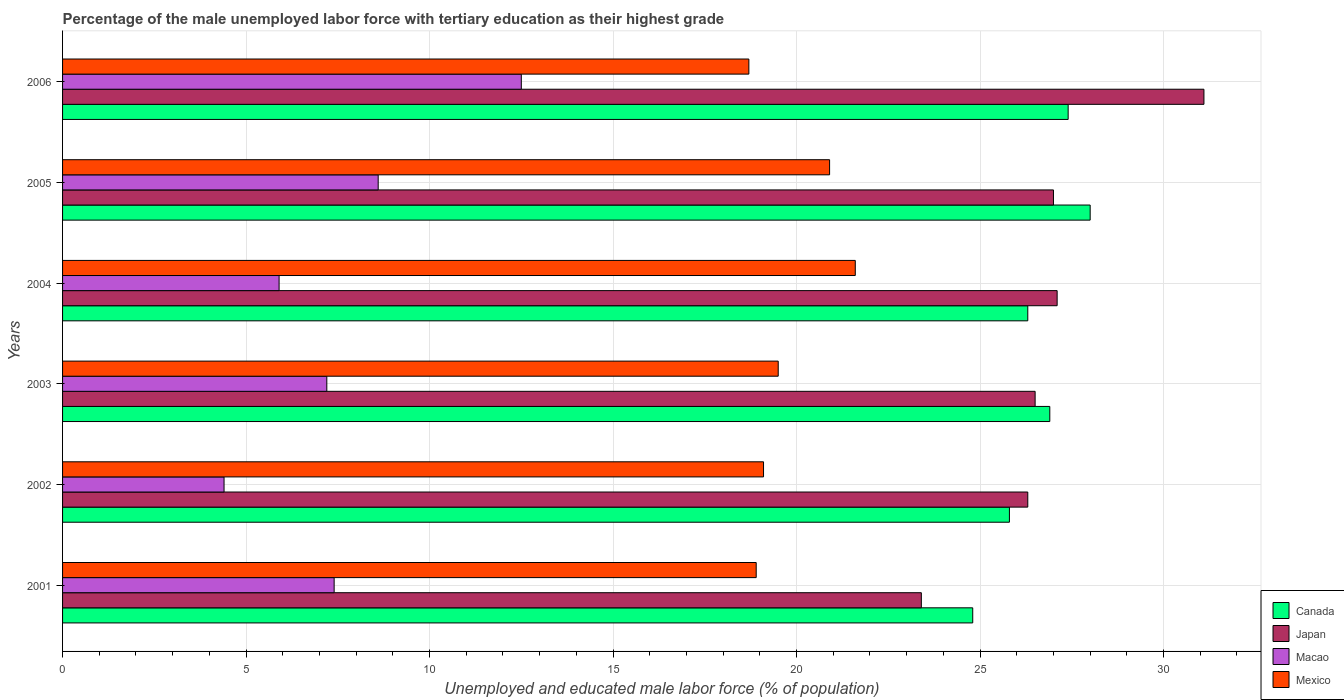How many different coloured bars are there?
Ensure brevity in your answer.  4. Are the number of bars per tick equal to the number of legend labels?
Your response must be concise. Yes. Are the number of bars on each tick of the Y-axis equal?
Provide a short and direct response. Yes. What is the label of the 3rd group of bars from the top?
Make the answer very short. 2004. What is the percentage of the unemployed male labor force with tertiary education in Canada in 2004?
Give a very brief answer. 26.3. Across all years, what is the maximum percentage of the unemployed male labor force with tertiary education in Canada?
Provide a short and direct response. 28. Across all years, what is the minimum percentage of the unemployed male labor force with tertiary education in Macao?
Offer a terse response. 4.4. In which year was the percentage of the unemployed male labor force with tertiary education in Japan maximum?
Your answer should be very brief. 2006. What is the total percentage of the unemployed male labor force with tertiary education in Canada in the graph?
Your answer should be very brief. 159.2. What is the difference between the percentage of the unemployed male labor force with tertiary education in Canada in 2004 and that in 2005?
Your response must be concise. -1.7. What is the difference between the percentage of the unemployed male labor force with tertiary education in Mexico in 2001 and the percentage of the unemployed male labor force with tertiary education in Canada in 2003?
Provide a short and direct response. -8. What is the average percentage of the unemployed male labor force with tertiary education in Macao per year?
Provide a short and direct response. 7.67. In the year 2004, what is the difference between the percentage of the unemployed male labor force with tertiary education in Japan and percentage of the unemployed male labor force with tertiary education in Mexico?
Your answer should be compact. 5.5. In how many years, is the percentage of the unemployed male labor force with tertiary education in Macao greater than 24 %?
Offer a terse response. 0. What is the ratio of the percentage of the unemployed male labor force with tertiary education in Japan in 2002 to that in 2003?
Offer a terse response. 0.99. Is the percentage of the unemployed male labor force with tertiary education in Canada in 2002 less than that in 2004?
Your response must be concise. Yes. Is the difference between the percentage of the unemployed male labor force with tertiary education in Japan in 2004 and 2006 greater than the difference between the percentage of the unemployed male labor force with tertiary education in Mexico in 2004 and 2006?
Your response must be concise. No. What is the difference between the highest and the second highest percentage of the unemployed male labor force with tertiary education in Mexico?
Keep it short and to the point. 0.7. What is the difference between the highest and the lowest percentage of the unemployed male labor force with tertiary education in Mexico?
Your response must be concise. 2.9. In how many years, is the percentage of the unemployed male labor force with tertiary education in Japan greater than the average percentage of the unemployed male labor force with tertiary education in Japan taken over all years?
Provide a succinct answer. 3. Is the sum of the percentage of the unemployed male labor force with tertiary education in Macao in 2002 and 2006 greater than the maximum percentage of the unemployed male labor force with tertiary education in Japan across all years?
Provide a succinct answer. No. Is it the case that in every year, the sum of the percentage of the unemployed male labor force with tertiary education in Japan and percentage of the unemployed male labor force with tertiary education in Macao is greater than the sum of percentage of the unemployed male labor force with tertiary education in Canada and percentage of the unemployed male labor force with tertiary education in Mexico?
Give a very brief answer. No. Is it the case that in every year, the sum of the percentage of the unemployed male labor force with tertiary education in Mexico and percentage of the unemployed male labor force with tertiary education in Macao is greater than the percentage of the unemployed male labor force with tertiary education in Canada?
Provide a short and direct response. No. How many years are there in the graph?
Offer a terse response. 6. Does the graph contain grids?
Offer a very short reply. Yes. How many legend labels are there?
Give a very brief answer. 4. What is the title of the graph?
Keep it short and to the point. Percentage of the male unemployed labor force with tertiary education as their highest grade. What is the label or title of the X-axis?
Provide a succinct answer. Unemployed and educated male labor force (% of population). What is the label or title of the Y-axis?
Provide a short and direct response. Years. What is the Unemployed and educated male labor force (% of population) of Canada in 2001?
Provide a succinct answer. 24.8. What is the Unemployed and educated male labor force (% of population) in Japan in 2001?
Offer a very short reply. 23.4. What is the Unemployed and educated male labor force (% of population) in Macao in 2001?
Offer a terse response. 7.4. What is the Unemployed and educated male labor force (% of population) in Mexico in 2001?
Provide a short and direct response. 18.9. What is the Unemployed and educated male labor force (% of population) of Canada in 2002?
Your answer should be very brief. 25.8. What is the Unemployed and educated male labor force (% of population) in Japan in 2002?
Offer a very short reply. 26.3. What is the Unemployed and educated male labor force (% of population) in Macao in 2002?
Your answer should be compact. 4.4. What is the Unemployed and educated male labor force (% of population) in Mexico in 2002?
Your answer should be compact. 19.1. What is the Unemployed and educated male labor force (% of population) of Canada in 2003?
Provide a succinct answer. 26.9. What is the Unemployed and educated male labor force (% of population) in Macao in 2003?
Your answer should be very brief. 7.2. What is the Unemployed and educated male labor force (% of population) in Canada in 2004?
Make the answer very short. 26.3. What is the Unemployed and educated male labor force (% of population) of Japan in 2004?
Your answer should be very brief. 27.1. What is the Unemployed and educated male labor force (% of population) in Macao in 2004?
Keep it short and to the point. 5.9. What is the Unemployed and educated male labor force (% of population) in Mexico in 2004?
Provide a succinct answer. 21.6. What is the Unemployed and educated male labor force (% of population) in Canada in 2005?
Your response must be concise. 28. What is the Unemployed and educated male labor force (% of population) in Macao in 2005?
Ensure brevity in your answer.  8.6. What is the Unemployed and educated male labor force (% of population) of Mexico in 2005?
Offer a very short reply. 20.9. What is the Unemployed and educated male labor force (% of population) in Canada in 2006?
Your response must be concise. 27.4. What is the Unemployed and educated male labor force (% of population) in Japan in 2006?
Provide a short and direct response. 31.1. What is the Unemployed and educated male labor force (% of population) of Mexico in 2006?
Offer a very short reply. 18.7. Across all years, what is the maximum Unemployed and educated male labor force (% of population) in Canada?
Give a very brief answer. 28. Across all years, what is the maximum Unemployed and educated male labor force (% of population) in Japan?
Make the answer very short. 31.1. Across all years, what is the maximum Unemployed and educated male labor force (% of population) in Macao?
Your answer should be compact. 12.5. Across all years, what is the maximum Unemployed and educated male labor force (% of population) in Mexico?
Your response must be concise. 21.6. Across all years, what is the minimum Unemployed and educated male labor force (% of population) in Canada?
Your response must be concise. 24.8. Across all years, what is the minimum Unemployed and educated male labor force (% of population) of Japan?
Your response must be concise. 23.4. Across all years, what is the minimum Unemployed and educated male labor force (% of population) of Macao?
Give a very brief answer. 4.4. Across all years, what is the minimum Unemployed and educated male labor force (% of population) of Mexico?
Provide a short and direct response. 18.7. What is the total Unemployed and educated male labor force (% of population) in Canada in the graph?
Provide a short and direct response. 159.2. What is the total Unemployed and educated male labor force (% of population) of Japan in the graph?
Ensure brevity in your answer.  161.4. What is the total Unemployed and educated male labor force (% of population) in Macao in the graph?
Offer a very short reply. 46. What is the total Unemployed and educated male labor force (% of population) in Mexico in the graph?
Offer a terse response. 118.7. What is the difference between the Unemployed and educated male labor force (% of population) of Japan in 2001 and that in 2002?
Offer a very short reply. -2.9. What is the difference between the Unemployed and educated male labor force (% of population) in Macao in 2001 and that in 2002?
Provide a succinct answer. 3. What is the difference between the Unemployed and educated male labor force (% of population) of Japan in 2001 and that in 2003?
Give a very brief answer. -3.1. What is the difference between the Unemployed and educated male labor force (% of population) of Mexico in 2001 and that in 2003?
Your answer should be very brief. -0.6. What is the difference between the Unemployed and educated male labor force (% of population) in Canada in 2001 and that in 2004?
Your answer should be compact. -1.5. What is the difference between the Unemployed and educated male labor force (% of population) in Japan in 2001 and that in 2004?
Offer a terse response. -3.7. What is the difference between the Unemployed and educated male labor force (% of population) of Macao in 2001 and that in 2004?
Provide a short and direct response. 1.5. What is the difference between the Unemployed and educated male labor force (% of population) of Mexico in 2001 and that in 2004?
Offer a very short reply. -2.7. What is the difference between the Unemployed and educated male labor force (% of population) of Canada in 2001 and that in 2005?
Keep it short and to the point. -3.2. What is the difference between the Unemployed and educated male labor force (% of population) of Japan in 2001 and that in 2006?
Provide a succinct answer. -7.7. What is the difference between the Unemployed and educated male labor force (% of population) in Mexico in 2002 and that in 2003?
Provide a short and direct response. -0.4. What is the difference between the Unemployed and educated male labor force (% of population) in Japan in 2002 and that in 2004?
Make the answer very short. -0.8. What is the difference between the Unemployed and educated male labor force (% of population) in Macao in 2002 and that in 2004?
Provide a succinct answer. -1.5. What is the difference between the Unemployed and educated male labor force (% of population) in Mexico in 2002 and that in 2004?
Provide a short and direct response. -2.5. What is the difference between the Unemployed and educated male labor force (% of population) of Macao in 2002 and that in 2005?
Keep it short and to the point. -4.2. What is the difference between the Unemployed and educated male labor force (% of population) in Mexico in 2002 and that in 2005?
Your answer should be very brief. -1.8. What is the difference between the Unemployed and educated male labor force (% of population) in Canada in 2002 and that in 2006?
Make the answer very short. -1.6. What is the difference between the Unemployed and educated male labor force (% of population) in Japan in 2002 and that in 2006?
Keep it short and to the point. -4.8. What is the difference between the Unemployed and educated male labor force (% of population) in Japan in 2003 and that in 2004?
Your answer should be compact. -0.6. What is the difference between the Unemployed and educated male labor force (% of population) in Mexico in 2003 and that in 2004?
Provide a succinct answer. -2.1. What is the difference between the Unemployed and educated male labor force (% of population) of Macao in 2003 and that in 2005?
Make the answer very short. -1.4. What is the difference between the Unemployed and educated male labor force (% of population) of Canada in 2004 and that in 2005?
Your answer should be compact. -1.7. What is the difference between the Unemployed and educated male labor force (% of population) of Japan in 2004 and that in 2005?
Provide a short and direct response. 0.1. What is the difference between the Unemployed and educated male labor force (% of population) of Mexico in 2004 and that in 2005?
Offer a very short reply. 0.7. What is the difference between the Unemployed and educated male labor force (% of population) of Japan in 2004 and that in 2006?
Make the answer very short. -4. What is the difference between the Unemployed and educated male labor force (% of population) of Mexico in 2004 and that in 2006?
Offer a terse response. 2.9. What is the difference between the Unemployed and educated male labor force (% of population) of Canada in 2005 and that in 2006?
Make the answer very short. 0.6. What is the difference between the Unemployed and educated male labor force (% of population) in Japan in 2005 and that in 2006?
Offer a very short reply. -4.1. What is the difference between the Unemployed and educated male labor force (% of population) of Macao in 2005 and that in 2006?
Your answer should be very brief. -3.9. What is the difference between the Unemployed and educated male labor force (% of population) in Mexico in 2005 and that in 2006?
Your answer should be compact. 2.2. What is the difference between the Unemployed and educated male labor force (% of population) of Canada in 2001 and the Unemployed and educated male labor force (% of population) of Macao in 2002?
Your answer should be very brief. 20.4. What is the difference between the Unemployed and educated male labor force (% of population) of Canada in 2001 and the Unemployed and educated male labor force (% of population) of Mexico in 2002?
Offer a terse response. 5.7. What is the difference between the Unemployed and educated male labor force (% of population) in Japan in 2001 and the Unemployed and educated male labor force (% of population) in Macao in 2002?
Make the answer very short. 19. What is the difference between the Unemployed and educated male labor force (% of population) of Macao in 2001 and the Unemployed and educated male labor force (% of population) of Mexico in 2002?
Give a very brief answer. -11.7. What is the difference between the Unemployed and educated male labor force (% of population) of Canada in 2001 and the Unemployed and educated male labor force (% of population) of Japan in 2003?
Your answer should be compact. -1.7. What is the difference between the Unemployed and educated male labor force (% of population) of Japan in 2001 and the Unemployed and educated male labor force (% of population) of Mexico in 2003?
Your response must be concise. 3.9. What is the difference between the Unemployed and educated male labor force (% of population) of Japan in 2001 and the Unemployed and educated male labor force (% of population) of Macao in 2004?
Your answer should be very brief. 17.5. What is the difference between the Unemployed and educated male labor force (% of population) in Canada in 2001 and the Unemployed and educated male labor force (% of population) in Mexico in 2005?
Make the answer very short. 3.9. What is the difference between the Unemployed and educated male labor force (% of population) of Japan in 2001 and the Unemployed and educated male labor force (% of population) of Macao in 2005?
Offer a terse response. 14.8. What is the difference between the Unemployed and educated male labor force (% of population) of Canada in 2002 and the Unemployed and educated male labor force (% of population) of Macao in 2003?
Offer a very short reply. 18.6. What is the difference between the Unemployed and educated male labor force (% of population) in Japan in 2002 and the Unemployed and educated male labor force (% of population) in Macao in 2003?
Provide a succinct answer. 19.1. What is the difference between the Unemployed and educated male labor force (% of population) of Japan in 2002 and the Unemployed and educated male labor force (% of population) of Mexico in 2003?
Give a very brief answer. 6.8. What is the difference between the Unemployed and educated male labor force (% of population) of Macao in 2002 and the Unemployed and educated male labor force (% of population) of Mexico in 2003?
Give a very brief answer. -15.1. What is the difference between the Unemployed and educated male labor force (% of population) of Canada in 2002 and the Unemployed and educated male labor force (% of population) of Japan in 2004?
Offer a terse response. -1.3. What is the difference between the Unemployed and educated male labor force (% of population) of Canada in 2002 and the Unemployed and educated male labor force (% of population) of Macao in 2004?
Your answer should be compact. 19.9. What is the difference between the Unemployed and educated male labor force (% of population) of Japan in 2002 and the Unemployed and educated male labor force (% of population) of Macao in 2004?
Give a very brief answer. 20.4. What is the difference between the Unemployed and educated male labor force (% of population) in Macao in 2002 and the Unemployed and educated male labor force (% of population) in Mexico in 2004?
Give a very brief answer. -17.2. What is the difference between the Unemployed and educated male labor force (% of population) in Canada in 2002 and the Unemployed and educated male labor force (% of population) in Japan in 2005?
Ensure brevity in your answer.  -1.2. What is the difference between the Unemployed and educated male labor force (% of population) in Canada in 2002 and the Unemployed and educated male labor force (% of population) in Macao in 2005?
Make the answer very short. 17.2. What is the difference between the Unemployed and educated male labor force (% of population) of Japan in 2002 and the Unemployed and educated male labor force (% of population) of Mexico in 2005?
Provide a short and direct response. 5.4. What is the difference between the Unemployed and educated male labor force (% of population) in Macao in 2002 and the Unemployed and educated male labor force (% of population) in Mexico in 2005?
Make the answer very short. -16.5. What is the difference between the Unemployed and educated male labor force (% of population) in Canada in 2002 and the Unemployed and educated male labor force (% of population) in Mexico in 2006?
Provide a short and direct response. 7.1. What is the difference between the Unemployed and educated male labor force (% of population) of Japan in 2002 and the Unemployed and educated male labor force (% of population) of Macao in 2006?
Offer a terse response. 13.8. What is the difference between the Unemployed and educated male labor force (% of population) of Macao in 2002 and the Unemployed and educated male labor force (% of population) of Mexico in 2006?
Your response must be concise. -14.3. What is the difference between the Unemployed and educated male labor force (% of population) in Canada in 2003 and the Unemployed and educated male labor force (% of population) in Japan in 2004?
Provide a short and direct response. -0.2. What is the difference between the Unemployed and educated male labor force (% of population) of Japan in 2003 and the Unemployed and educated male labor force (% of population) of Macao in 2004?
Keep it short and to the point. 20.6. What is the difference between the Unemployed and educated male labor force (% of population) of Macao in 2003 and the Unemployed and educated male labor force (% of population) of Mexico in 2004?
Your response must be concise. -14.4. What is the difference between the Unemployed and educated male labor force (% of population) in Canada in 2003 and the Unemployed and educated male labor force (% of population) in Japan in 2005?
Your response must be concise. -0.1. What is the difference between the Unemployed and educated male labor force (% of population) in Canada in 2003 and the Unemployed and educated male labor force (% of population) in Macao in 2005?
Offer a very short reply. 18.3. What is the difference between the Unemployed and educated male labor force (% of population) of Japan in 2003 and the Unemployed and educated male labor force (% of population) of Macao in 2005?
Offer a very short reply. 17.9. What is the difference between the Unemployed and educated male labor force (% of population) of Macao in 2003 and the Unemployed and educated male labor force (% of population) of Mexico in 2005?
Offer a terse response. -13.7. What is the difference between the Unemployed and educated male labor force (% of population) in Canada in 2003 and the Unemployed and educated male labor force (% of population) in Japan in 2006?
Your answer should be very brief. -4.2. What is the difference between the Unemployed and educated male labor force (% of population) of Canada in 2003 and the Unemployed and educated male labor force (% of population) of Macao in 2006?
Offer a very short reply. 14.4. What is the difference between the Unemployed and educated male labor force (% of population) in Canada in 2003 and the Unemployed and educated male labor force (% of population) in Mexico in 2006?
Offer a terse response. 8.2. What is the difference between the Unemployed and educated male labor force (% of population) of Macao in 2003 and the Unemployed and educated male labor force (% of population) of Mexico in 2006?
Offer a very short reply. -11.5. What is the difference between the Unemployed and educated male labor force (% of population) of Canada in 2004 and the Unemployed and educated male labor force (% of population) of Macao in 2005?
Make the answer very short. 17.7. What is the difference between the Unemployed and educated male labor force (% of population) in Japan in 2004 and the Unemployed and educated male labor force (% of population) in Mexico in 2005?
Make the answer very short. 6.2. What is the difference between the Unemployed and educated male labor force (% of population) of Canada in 2004 and the Unemployed and educated male labor force (% of population) of Japan in 2006?
Ensure brevity in your answer.  -4.8. What is the difference between the Unemployed and educated male labor force (% of population) in Japan in 2004 and the Unemployed and educated male labor force (% of population) in Macao in 2006?
Keep it short and to the point. 14.6. What is the difference between the Unemployed and educated male labor force (% of population) of Japan in 2004 and the Unemployed and educated male labor force (% of population) of Mexico in 2006?
Your response must be concise. 8.4. What is the difference between the Unemployed and educated male labor force (% of population) in Macao in 2004 and the Unemployed and educated male labor force (% of population) in Mexico in 2006?
Your answer should be very brief. -12.8. What is the difference between the Unemployed and educated male labor force (% of population) of Canada in 2005 and the Unemployed and educated male labor force (% of population) of Japan in 2006?
Provide a short and direct response. -3.1. What is the difference between the Unemployed and educated male labor force (% of population) of Japan in 2005 and the Unemployed and educated male labor force (% of population) of Mexico in 2006?
Give a very brief answer. 8.3. What is the average Unemployed and educated male labor force (% of population) in Canada per year?
Provide a short and direct response. 26.53. What is the average Unemployed and educated male labor force (% of population) in Japan per year?
Provide a succinct answer. 26.9. What is the average Unemployed and educated male labor force (% of population) of Macao per year?
Offer a terse response. 7.67. What is the average Unemployed and educated male labor force (% of population) of Mexico per year?
Your answer should be very brief. 19.78. In the year 2001, what is the difference between the Unemployed and educated male labor force (% of population) in Macao and Unemployed and educated male labor force (% of population) in Mexico?
Provide a succinct answer. -11.5. In the year 2002, what is the difference between the Unemployed and educated male labor force (% of population) of Canada and Unemployed and educated male labor force (% of population) of Macao?
Make the answer very short. 21.4. In the year 2002, what is the difference between the Unemployed and educated male labor force (% of population) in Canada and Unemployed and educated male labor force (% of population) in Mexico?
Keep it short and to the point. 6.7. In the year 2002, what is the difference between the Unemployed and educated male labor force (% of population) in Japan and Unemployed and educated male labor force (% of population) in Macao?
Offer a very short reply. 21.9. In the year 2002, what is the difference between the Unemployed and educated male labor force (% of population) of Japan and Unemployed and educated male labor force (% of population) of Mexico?
Your response must be concise. 7.2. In the year 2002, what is the difference between the Unemployed and educated male labor force (% of population) in Macao and Unemployed and educated male labor force (% of population) in Mexico?
Keep it short and to the point. -14.7. In the year 2003, what is the difference between the Unemployed and educated male labor force (% of population) in Canada and Unemployed and educated male labor force (% of population) in Macao?
Your answer should be compact. 19.7. In the year 2003, what is the difference between the Unemployed and educated male labor force (% of population) in Canada and Unemployed and educated male labor force (% of population) in Mexico?
Offer a terse response. 7.4. In the year 2003, what is the difference between the Unemployed and educated male labor force (% of population) in Japan and Unemployed and educated male labor force (% of population) in Macao?
Offer a very short reply. 19.3. In the year 2003, what is the difference between the Unemployed and educated male labor force (% of population) in Japan and Unemployed and educated male labor force (% of population) in Mexico?
Your response must be concise. 7. In the year 2004, what is the difference between the Unemployed and educated male labor force (% of population) in Canada and Unemployed and educated male labor force (% of population) in Macao?
Give a very brief answer. 20.4. In the year 2004, what is the difference between the Unemployed and educated male labor force (% of population) in Canada and Unemployed and educated male labor force (% of population) in Mexico?
Make the answer very short. 4.7. In the year 2004, what is the difference between the Unemployed and educated male labor force (% of population) in Japan and Unemployed and educated male labor force (% of population) in Macao?
Provide a short and direct response. 21.2. In the year 2004, what is the difference between the Unemployed and educated male labor force (% of population) in Japan and Unemployed and educated male labor force (% of population) in Mexico?
Ensure brevity in your answer.  5.5. In the year 2004, what is the difference between the Unemployed and educated male labor force (% of population) of Macao and Unemployed and educated male labor force (% of population) of Mexico?
Your answer should be very brief. -15.7. In the year 2005, what is the difference between the Unemployed and educated male labor force (% of population) of Canada and Unemployed and educated male labor force (% of population) of Japan?
Offer a terse response. 1. In the year 2005, what is the difference between the Unemployed and educated male labor force (% of population) of Canada and Unemployed and educated male labor force (% of population) of Macao?
Your response must be concise. 19.4. In the year 2006, what is the difference between the Unemployed and educated male labor force (% of population) in Canada and Unemployed and educated male labor force (% of population) in Japan?
Ensure brevity in your answer.  -3.7. In the year 2006, what is the difference between the Unemployed and educated male labor force (% of population) of Canada and Unemployed and educated male labor force (% of population) of Mexico?
Your answer should be very brief. 8.7. In the year 2006, what is the difference between the Unemployed and educated male labor force (% of population) of Japan and Unemployed and educated male labor force (% of population) of Mexico?
Make the answer very short. 12.4. What is the ratio of the Unemployed and educated male labor force (% of population) of Canada in 2001 to that in 2002?
Offer a very short reply. 0.96. What is the ratio of the Unemployed and educated male labor force (% of population) of Japan in 2001 to that in 2002?
Provide a succinct answer. 0.89. What is the ratio of the Unemployed and educated male labor force (% of population) in Macao in 2001 to that in 2002?
Make the answer very short. 1.68. What is the ratio of the Unemployed and educated male labor force (% of population) of Mexico in 2001 to that in 2002?
Your response must be concise. 0.99. What is the ratio of the Unemployed and educated male labor force (% of population) in Canada in 2001 to that in 2003?
Provide a short and direct response. 0.92. What is the ratio of the Unemployed and educated male labor force (% of population) in Japan in 2001 to that in 2003?
Offer a very short reply. 0.88. What is the ratio of the Unemployed and educated male labor force (% of population) in Macao in 2001 to that in 2003?
Ensure brevity in your answer.  1.03. What is the ratio of the Unemployed and educated male labor force (% of population) of Mexico in 2001 to that in 2003?
Your response must be concise. 0.97. What is the ratio of the Unemployed and educated male labor force (% of population) of Canada in 2001 to that in 2004?
Your answer should be very brief. 0.94. What is the ratio of the Unemployed and educated male labor force (% of population) in Japan in 2001 to that in 2004?
Offer a terse response. 0.86. What is the ratio of the Unemployed and educated male labor force (% of population) of Macao in 2001 to that in 2004?
Offer a very short reply. 1.25. What is the ratio of the Unemployed and educated male labor force (% of population) of Canada in 2001 to that in 2005?
Make the answer very short. 0.89. What is the ratio of the Unemployed and educated male labor force (% of population) in Japan in 2001 to that in 2005?
Give a very brief answer. 0.87. What is the ratio of the Unemployed and educated male labor force (% of population) of Macao in 2001 to that in 2005?
Ensure brevity in your answer.  0.86. What is the ratio of the Unemployed and educated male labor force (% of population) of Mexico in 2001 to that in 2005?
Give a very brief answer. 0.9. What is the ratio of the Unemployed and educated male labor force (% of population) of Canada in 2001 to that in 2006?
Your response must be concise. 0.91. What is the ratio of the Unemployed and educated male labor force (% of population) in Japan in 2001 to that in 2006?
Ensure brevity in your answer.  0.75. What is the ratio of the Unemployed and educated male labor force (% of population) in Macao in 2001 to that in 2006?
Provide a short and direct response. 0.59. What is the ratio of the Unemployed and educated male labor force (% of population) in Mexico in 2001 to that in 2006?
Offer a terse response. 1.01. What is the ratio of the Unemployed and educated male labor force (% of population) in Canada in 2002 to that in 2003?
Keep it short and to the point. 0.96. What is the ratio of the Unemployed and educated male labor force (% of population) of Japan in 2002 to that in 2003?
Your response must be concise. 0.99. What is the ratio of the Unemployed and educated male labor force (% of population) of Macao in 2002 to that in 2003?
Provide a short and direct response. 0.61. What is the ratio of the Unemployed and educated male labor force (% of population) of Mexico in 2002 to that in 2003?
Offer a very short reply. 0.98. What is the ratio of the Unemployed and educated male labor force (% of population) in Japan in 2002 to that in 2004?
Provide a succinct answer. 0.97. What is the ratio of the Unemployed and educated male labor force (% of population) in Macao in 2002 to that in 2004?
Give a very brief answer. 0.75. What is the ratio of the Unemployed and educated male labor force (% of population) in Mexico in 2002 to that in 2004?
Give a very brief answer. 0.88. What is the ratio of the Unemployed and educated male labor force (% of population) in Canada in 2002 to that in 2005?
Provide a succinct answer. 0.92. What is the ratio of the Unemployed and educated male labor force (% of population) of Japan in 2002 to that in 2005?
Keep it short and to the point. 0.97. What is the ratio of the Unemployed and educated male labor force (% of population) of Macao in 2002 to that in 2005?
Offer a very short reply. 0.51. What is the ratio of the Unemployed and educated male labor force (% of population) of Mexico in 2002 to that in 2005?
Ensure brevity in your answer.  0.91. What is the ratio of the Unemployed and educated male labor force (% of population) of Canada in 2002 to that in 2006?
Offer a very short reply. 0.94. What is the ratio of the Unemployed and educated male labor force (% of population) in Japan in 2002 to that in 2006?
Give a very brief answer. 0.85. What is the ratio of the Unemployed and educated male labor force (% of population) in Macao in 2002 to that in 2006?
Make the answer very short. 0.35. What is the ratio of the Unemployed and educated male labor force (% of population) of Mexico in 2002 to that in 2006?
Provide a short and direct response. 1.02. What is the ratio of the Unemployed and educated male labor force (% of population) in Canada in 2003 to that in 2004?
Make the answer very short. 1.02. What is the ratio of the Unemployed and educated male labor force (% of population) in Japan in 2003 to that in 2004?
Keep it short and to the point. 0.98. What is the ratio of the Unemployed and educated male labor force (% of population) of Macao in 2003 to that in 2004?
Give a very brief answer. 1.22. What is the ratio of the Unemployed and educated male labor force (% of population) of Mexico in 2003 to that in 2004?
Make the answer very short. 0.9. What is the ratio of the Unemployed and educated male labor force (% of population) of Canada in 2003 to that in 2005?
Your answer should be compact. 0.96. What is the ratio of the Unemployed and educated male labor force (% of population) in Japan in 2003 to that in 2005?
Make the answer very short. 0.98. What is the ratio of the Unemployed and educated male labor force (% of population) of Macao in 2003 to that in 2005?
Ensure brevity in your answer.  0.84. What is the ratio of the Unemployed and educated male labor force (% of population) of Mexico in 2003 to that in 2005?
Provide a succinct answer. 0.93. What is the ratio of the Unemployed and educated male labor force (% of population) in Canada in 2003 to that in 2006?
Provide a succinct answer. 0.98. What is the ratio of the Unemployed and educated male labor force (% of population) of Japan in 2003 to that in 2006?
Keep it short and to the point. 0.85. What is the ratio of the Unemployed and educated male labor force (% of population) in Macao in 2003 to that in 2006?
Make the answer very short. 0.58. What is the ratio of the Unemployed and educated male labor force (% of population) of Mexico in 2003 to that in 2006?
Your answer should be compact. 1.04. What is the ratio of the Unemployed and educated male labor force (% of population) in Canada in 2004 to that in 2005?
Your response must be concise. 0.94. What is the ratio of the Unemployed and educated male labor force (% of population) of Japan in 2004 to that in 2005?
Your response must be concise. 1. What is the ratio of the Unemployed and educated male labor force (% of population) in Macao in 2004 to that in 2005?
Provide a succinct answer. 0.69. What is the ratio of the Unemployed and educated male labor force (% of population) of Mexico in 2004 to that in 2005?
Keep it short and to the point. 1.03. What is the ratio of the Unemployed and educated male labor force (% of population) in Canada in 2004 to that in 2006?
Ensure brevity in your answer.  0.96. What is the ratio of the Unemployed and educated male labor force (% of population) in Japan in 2004 to that in 2006?
Make the answer very short. 0.87. What is the ratio of the Unemployed and educated male labor force (% of population) in Macao in 2004 to that in 2006?
Give a very brief answer. 0.47. What is the ratio of the Unemployed and educated male labor force (% of population) in Mexico in 2004 to that in 2006?
Make the answer very short. 1.16. What is the ratio of the Unemployed and educated male labor force (% of population) of Canada in 2005 to that in 2006?
Make the answer very short. 1.02. What is the ratio of the Unemployed and educated male labor force (% of population) of Japan in 2005 to that in 2006?
Give a very brief answer. 0.87. What is the ratio of the Unemployed and educated male labor force (% of population) of Macao in 2005 to that in 2006?
Your answer should be very brief. 0.69. What is the ratio of the Unemployed and educated male labor force (% of population) in Mexico in 2005 to that in 2006?
Make the answer very short. 1.12. What is the difference between the highest and the second highest Unemployed and educated male labor force (% of population) in Canada?
Offer a very short reply. 0.6. What is the difference between the highest and the second highest Unemployed and educated male labor force (% of population) of Japan?
Offer a terse response. 4. What is the difference between the highest and the second highest Unemployed and educated male labor force (% of population) of Macao?
Provide a short and direct response. 3.9. What is the difference between the highest and the second highest Unemployed and educated male labor force (% of population) in Mexico?
Your answer should be compact. 0.7. What is the difference between the highest and the lowest Unemployed and educated male labor force (% of population) of Canada?
Provide a succinct answer. 3.2. 